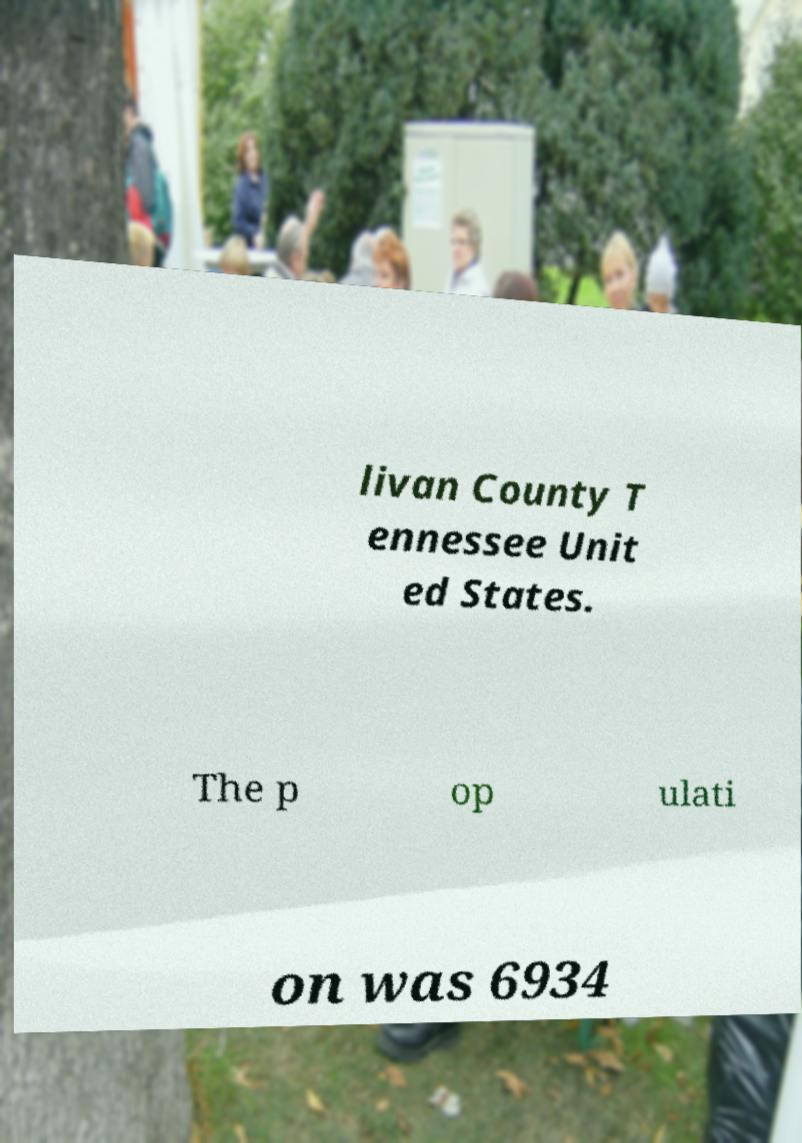I need the written content from this picture converted into text. Can you do that? livan County T ennessee Unit ed States. The p op ulati on was 6934 